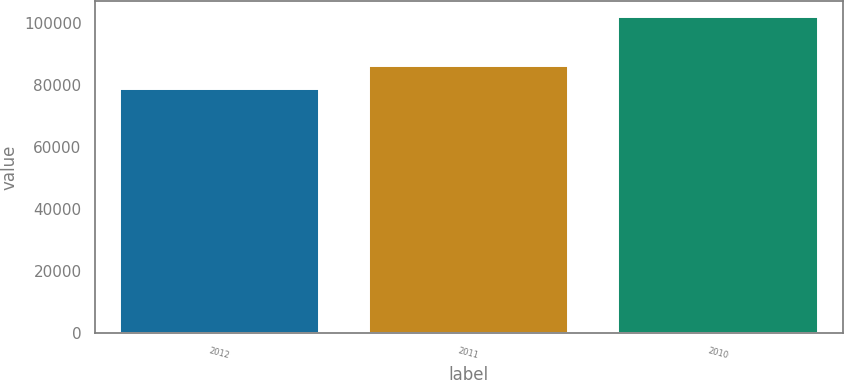<chart> <loc_0><loc_0><loc_500><loc_500><bar_chart><fcel>2012<fcel>2011<fcel>2010<nl><fcel>78627<fcel>86143<fcel>101831<nl></chart> 